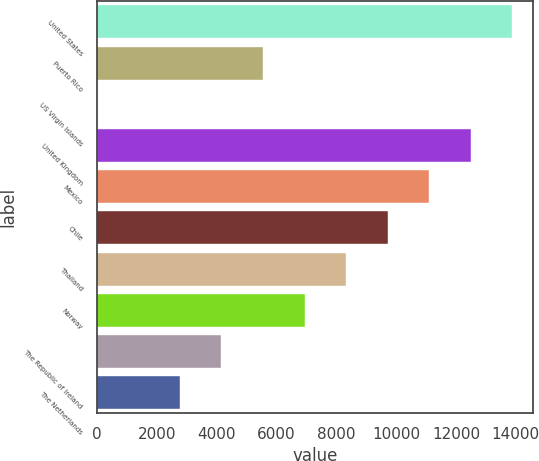Convert chart to OTSL. <chart><loc_0><loc_0><loc_500><loc_500><bar_chart><fcel>United States<fcel>Puerto Rico<fcel>US Virgin Islands<fcel>United Kingdom<fcel>Mexico<fcel>Chile<fcel>Thailand<fcel>Norway<fcel>The Republic of Ireland<fcel>The Netherlands<nl><fcel>13882<fcel>5553.4<fcel>1<fcel>12493.9<fcel>11105.8<fcel>9717.7<fcel>8329.6<fcel>6941.5<fcel>4165.3<fcel>2777.2<nl></chart> 